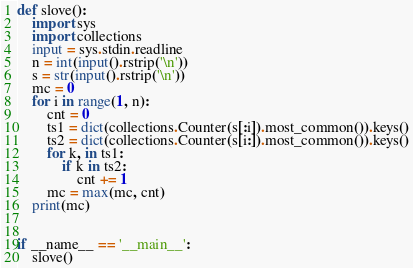<code> <loc_0><loc_0><loc_500><loc_500><_Python_>def slove():
    import sys
    import collections
    input = sys.stdin.readline
    n = int(input().rstrip('\n'))
    s = str(input().rstrip('\n'))
    mc = 0
    for i in range(1, n):
        cnt = 0
        ts1 = dict(collections.Counter(s[:i]).most_common()).keys()
        ts2 = dict(collections.Counter(s[i:]).most_common()).keys()
        for k, in ts1:
            if k in ts2:
                cnt += 1
        mc = max(mc, cnt)
    print(mc)


if __name__ == '__main__':
    slove()
</code> 